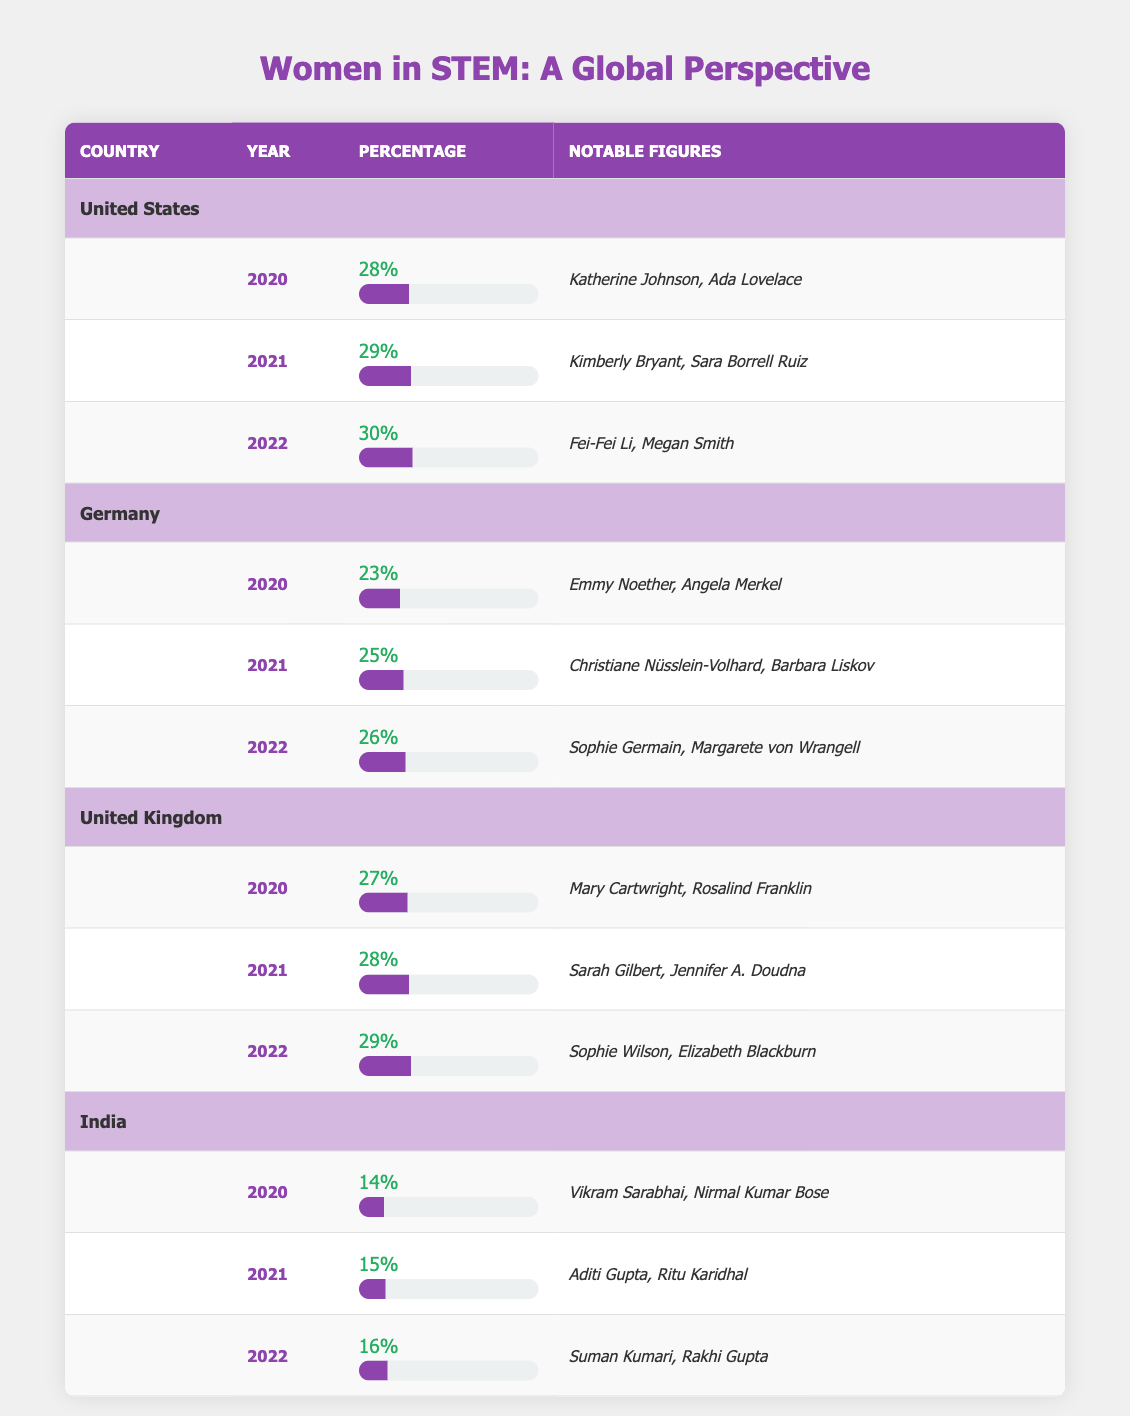What was the percentage of women in STEM in the United States in 2022? The table shows that in 2022, the percentage of women in STEM in the United States was 30%.
Answer: 30% Which country had the highest representation of women in STEM in 2021? In 2021, the United States had the highest percentage of women in STEM at 29%, compared to Germany (25%), the United Kingdom (28%), and India (15%).
Answer: United States What is the average percentage of women in STEM for the years 2020 to 2022 in India? The percentages for India from 2020 to 2022 are 14%, 15%, and 16%. To find the average, we sum these percentages (14 + 15 + 16 = 45) and divide by 3. So, the average is 45/3 = 15%.
Answer: 15% Did Germany's representation of women in STEM increase every year from 2020 to 2022? The table shows Germany's representation: 23% in 2020, 25% in 2021, and 26% in 2022, indicating a year-over-year increase. Therefore, the answer is yes.
Answer: Yes What was the difference in representation of women in STEM between the United Kingdom in 2020 and India in 2022? The United Kingdom had 27% representation in 2020, and India had 16% in 2022. The difference is calculated as 27% - 16% = 11%.
Answer: 11% 